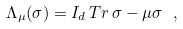<formula> <loc_0><loc_0><loc_500><loc_500>\Lambda _ { \mu } ( \sigma ) = I _ { d } \, T r \, \sigma - \mu \sigma \ ,</formula> 